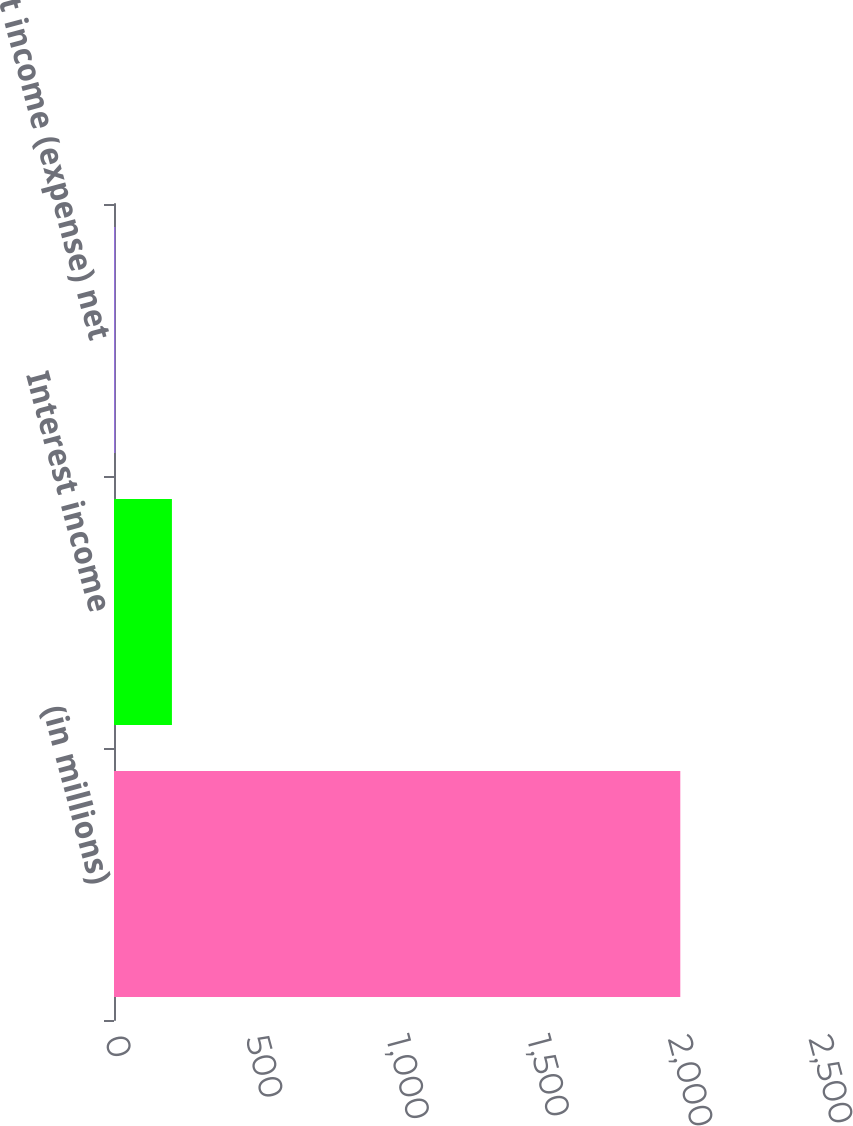Convert chart to OTSL. <chart><loc_0><loc_0><loc_500><loc_500><bar_chart><fcel>(in millions)<fcel>Interest income<fcel>Interest income (expense) net<nl><fcel>2011<fcel>205.69<fcel>5.1<nl></chart> 